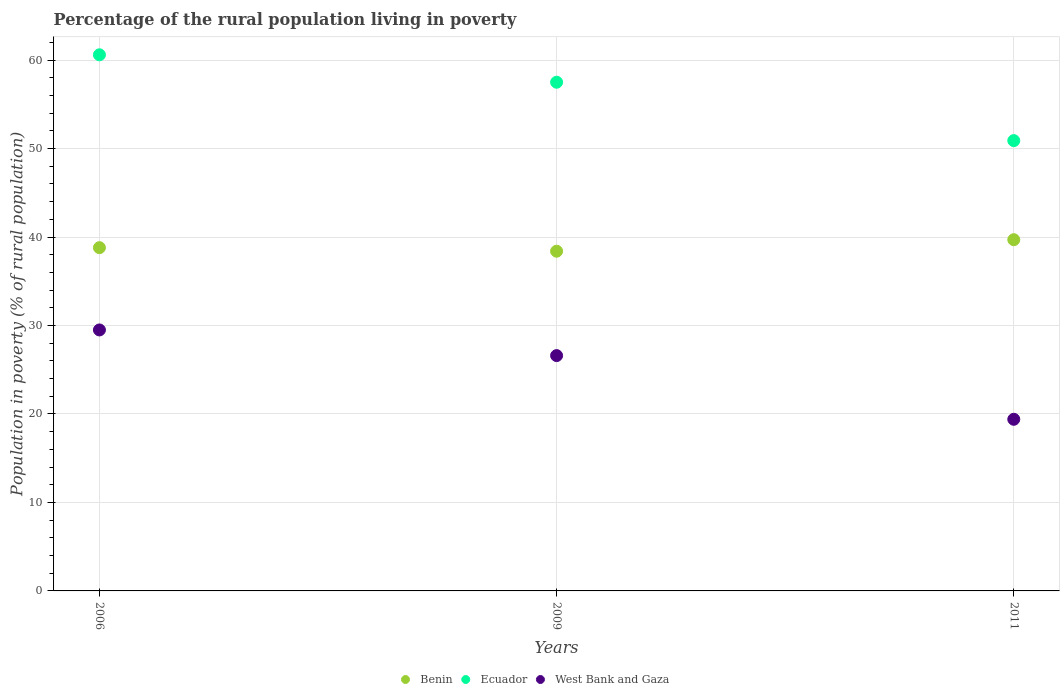How many different coloured dotlines are there?
Your answer should be very brief. 3. Is the number of dotlines equal to the number of legend labels?
Keep it short and to the point. Yes. Across all years, what is the maximum percentage of the rural population living in poverty in West Bank and Gaza?
Provide a short and direct response. 29.5. Across all years, what is the minimum percentage of the rural population living in poverty in Benin?
Ensure brevity in your answer.  38.4. In which year was the percentage of the rural population living in poverty in Benin minimum?
Give a very brief answer. 2009. What is the total percentage of the rural population living in poverty in West Bank and Gaza in the graph?
Your answer should be compact. 75.5. What is the difference between the percentage of the rural population living in poverty in Ecuador in 2006 and that in 2011?
Provide a succinct answer. 9.7. What is the difference between the percentage of the rural population living in poverty in Benin in 2011 and the percentage of the rural population living in poverty in Ecuador in 2009?
Your response must be concise. -17.8. What is the average percentage of the rural population living in poverty in Ecuador per year?
Offer a very short reply. 56.33. In the year 2011, what is the difference between the percentage of the rural population living in poverty in Benin and percentage of the rural population living in poverty in West Bank and Gaza?
Keep it short and to the point. 20.3. In how many years, is the percentage of the rural population living in poverty in Benin greater than 44 %?
Ensure brevity in your answer.  0. What is the ratio of the percentage of the rural population living in poverty in West Bank and Gaza in 2009 to that in 2011?
Your answer should be very brief. 1.37. Is the percentage of the rural population living in poverty in Benin in 2006 less than that in 2009?
Your response must be concise. No. Is the difference between the percentage of the rural population living in poverty in Benin in 2006 and 2009 greater than the difference between the percentage of the rural population living in poverty in West Bank and Gaza in 2006 and 2009?
Keep it short and to the point. No. What is the difference between the highest and the second highest percentage of the rural population living in poverty in West Bank and Gaza?
Your answer should be compact. 2.9. What is the difference between the highest and the lowest percentage of the rural population living in poverty in West Bank and Gaza?
Your answer should be compact. 10.1. Is the sum of the percentage of the rural population living in poverty in Benin in 2009 and 2011 greater than the maximum percentage of the rural population living in poverty in Ecuador across all years?
Keep it short and to the point. Yes. Does the percentage of the rural population living in poverty in Ecuador monotonically increase over the years?
Your answer should be very brief. No. Is the percentage of the rural population living in poverty in Ecuador strictly less than the percentage of the rural population living in poverty in West Bank and Gaza over the years?
Make the answer very short. No. How many years are there in the graph?
Your answer should be compact. 3. Does the graph contain grids?
Offer a terse response. Yes. Where does the legend appear in the graph?
Offer a very short reply. Bottom center. How are the legend labels stacked?
Your answer should be compact. Horizontal. What is the title of the graph?
Your answer should be compact. Percentage of the rural population living in poverty. What is the label or title of the Y-axis?
Ensure brevity in your answer.  Population in poverty (% of rural population). What is the Population in poverty (% of rural population) in Benin in 2006?
Your answer should be very brief. 38.8. What is the Population in poverty (% of rural population) in Ecuador in 2006?
Provide a short and direct response. 60.6. What is the Population in poverty (% of rural population) of West Bank and Gaza in 2006?
Provide a succinct answer. 29.5. What is the Population in poverty (% of rural population) of Benin in 2009?
Offer a terse response. 38.4. What is the Population in poverty (% of rural population) in Ecuador in 2009?
Offer a very short reply. 57.5. What is the Population in poverty (% of rural population) in West Bank and Gaza in 2009?
Keep it short and to the point. 26.6. What is the Population in poverty (% of rural population) of Benin in 2011?
Your answer should be compact. 39.7. What is the Population in poverty (% of rural population) in Ecuador in 2011?
Your response must be concise. 50.9. Across all years, what is the maximum Population in poverty (% of rural population) of Benin?
Give a very brief answer. 39.7. Across all years, what is the maximum Population in poverty (% of rural population) of Ecuador?
Your response must be concise. 60.6. Across all years, what is the maximum Population in poverty (% of rural population) in West Bank and Gaza?
Your response must be concise. 29.5. Across all years, what is the minimum Population in poverty (% of rural population) of Benin?
Provide a succinct answer. 38.4. Across all years, what is the minimum Population in poverty (% of rural population) in Ecuador?
Offer a terse response. 50.9. What is the total Population in poverty (% of rural population) of Benin in the graph?
Offer a very short reply. 116.9. What is the total Population in poverty (% of rural population) in Ecuador in the graph?
Make the answer very short. 169. What is the total Population in poverty (% of rural population) in West Bank and Gaza in the graph?
Offer a terse response. 75.5. What is the difference between the Population in poverty (% of rural population) in West Bank and Gaza in 2006 and that in 2009?
Your response must be concise. 2.9. What is the difference between the Population in poverty (% of rural population) in Benin in 2006 and that in 2011?
Offer a terse response. -0.9. What is the difference between the Population in poverty (% of rural population) in Benin in 2009 and that in 2011?
Provide a short and direct response. -1.3. What is the difference between the Population in poverty (% of rural population) in Benin in 2006 and the Population in poverty (% of rural population) in Ecuador in 2009?
Your answer should be very brief. -18.7. What is the difference between the Population in poverty (% of rural population) in Benin in 2006 and the Population in poverty (% of rural population) in West Bank and Gaza in 2009?
Ensure brevity in your answer.  12.2. What is the difference between the Population in poverty (% of rural population) of Ecuador in 2006 and the Population in poverty (% of rural population) of West Bank and Gaza in 2009?
Make the answer very short. 34. What is the difference between the Population in poverty (% of rural population) in Benin in 2006 and the Population in poverty (% of rural population) in Ecuador in 2011?
Offer a very short reply. -12.1. What is the difference between the Population in poverty (% of rural population) of Ecuador in 2006 and the Population in poverty (% of rural population) of West Bank and Gaza in 2011?
Ensure brevity in your answer.  41.2. What is the difference between the Population in poverty (% of rural population) of Benin in 2009 and the Population in poverty (% of rural population) of Ecuador in 2011?
Ensure brevity in your answer.  -12.5. What is the difference between the Population in poverty (% of rural population) in Ecuador in 2009 and the Population in poverty (% of rural population) in West Bank and Gaza in 2011?
Your answer should be very brief. 38.1. What is the average Population in poverty (% of rural population) in Benin per year?
Your answer should be very brief. 38.97. What is the average Population in poverty (% of rural population) in Ecuador per year?
Give a very brief answer. 56.33. What is the average Population in poverty (% of rural population) in West Bank and Gaza per year?
Offer a very short reply. 25.17. In the year 2006, what is the difference between the Population in poverty (% of rural population) in Benin and Population in poverty (% of rural population) in Ecuador?
Provide a short and direct response. -21.8. In the year 2006, what is the difference between the Population in poverty (% of rural population) in Benin and Population in poverty (% of rural population) in West Bank and Gaza?
Your response must be concise. 9.3. In the year 2006, what is the difference between the Population in poverty (% of rural population) of Ecuador and Population in poverty (% of rural population) of West Bank and Gaza?
Provide a succinct answer. 31.1. In the year 2009, what is the difference between the Population in poverty (% of rural population) of Benin and Population in poverty (% of rural population) of Ecuador?
Keep it short and to the point. -19.1. In the year 2009, what is the difference between the Population in poverty (% of rural population) of Ecuador and Population in poverty (% of rural population) of West Bank and Gaza?
Offer a terse response. 30.9. In the year 2011, what is the difference between the Population in poverty (% of rural population) in Benin and Population in poverty (% of rural population) in Ecuador?
Provide a succinct answer. -11.2. In the year 2011, what is the difference between the Population in poverty (% of rural population) of Benin and Population in poverty (% of rural population) of West Bank and Gaza?
Make the answer very short. 20.3. In the year 2011, what is the difference between the Population in poverty (% of rural population) of Ecuador and Population in poverty (% of rural population) of West Bank and Gaza?
Provide a succinct answer. 31.5. What is the ratio of the Population in poverty (% of rural population) of Benin in 2006 to that in 2009?
Make the answer very short. 1.01. What is the ratio of the Population in poverty (% of rural population) of Ecuador in 2006 to that in 2009?
Your answer should be very brief. 1.05. What is the ratio of the Population in poverty (% of rural population) of West Bank and Gaza in 2006 to that in 2009?
Provide a short and direct response. 1.11. What is the ratio of the Population in poverty (% of rural population) of Benin in 2006 to that in 2011?
Your answer should be very brief. 0.98. What is the ratio of the Population in poverty (% of rural population) in Ecuador in 2006 to that in 2011?
Your answer should be compact. 1.19. What is the ratio of the Population in poverty (% of rural population) of West Bank and Gaza in 2006 to that in 2011?
Offer a very short reply. 1.52. What is the ratio of the Population in poverty (% of rural population) of Benin in 2009 to that in 2011?
Offer a terse response. 0.97. What is the ratio of the Population in poverty (% of rural population) in Ecuador in 2009 to that in 2011?
Give a very brief answer. 1.13. What is the ratio of the Population in poverty (% of rural population) of West Bank and Gaza in 2009 to that in 2011?
Offer a terse response. 1.37. What is the difference between the highest and the second highest Population in poverty (% of rural population) in West Bank and Gaza?
Provide a short and direct response. 2.9. What is the difference between the highest and the lowest Population in poverty (% of rural population) in West Bank and Gaza?
Your response must be concise. 10.1. 